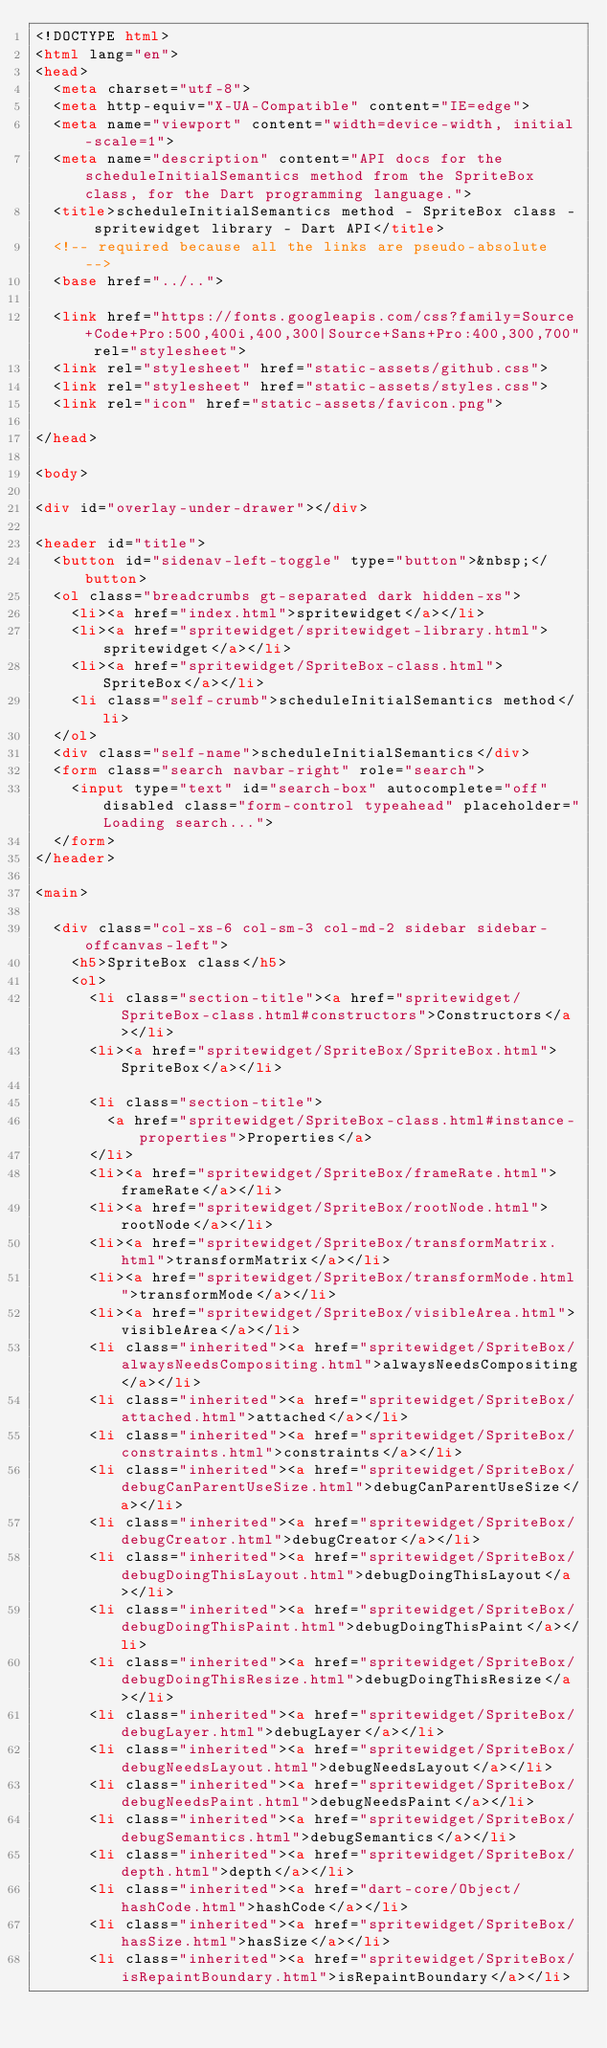Convert code to text. <code><loc_0><loc_0><loc_500><loc_500><_HTML_><!DOCTYPE html>
<html lang="en">
<head>
  <meta charset="utf-8">
  <meta http-equiv="X-UA-Compatible" content="IE=edge">
  <meta name="viewport" content="width=device-width, initial-scale=1">
  <meta name="description" content="API docs for the scheduleInitialSemantics method from the SpriteBox class, for the Dart programming language.">
  <title>scheduleInitialSemantics method - SpriteBox class - spritewidget library - Dart API</title>
  <!-- required because all the links are pseudo-absolute -->
  <base href="../..">

  <link href="https://fonts.googleapis.com/css?family=Source+Code+Pro:500,400i,400,300|Source+Sans+Pro:400,300,700" rel="stylesheet">
  <link rel="stylesheet" href="static-assets/github.css">
  <link rel="stylesheet" href="static-assets/styles.css">
  <link rel="icon" href="static-assets/favicon.png">

</head>

<body>

<div id="overlay-under-drawer"></div>

<header id="title">
  <button id="sidenav-left-toggle" type="button">&nbsp;</button>
  <ol class="breadcrumbs gt-separated dark hidden-xs">
    <li><a href="index.html">spritewidget</a></li>
    <li><a href="spritewidget/spritewidget-library.html">spritewidget</a></li>
    <li><a href="spritewidget/SpriteBox-class.html">SpriteBox</a></li>
    <li class="self-crumb">scheduleInitialSemantics method</li>
  </ol>
  <div class="self-name">scheduleInitialSemantics</div>
  <form class="search navbar-right" role="search">
    <input type="text" id="search-box" autocomplete="off" disabled class="form-control typeahead" placeholder="Loading search...">
  </form>
</header>

<main>

  <div class="col-xs-6 col-sm-3 col-md-2 sidebar sidebar-offcanvas-left">
    <h5>SpriteBox class</h5>
    <ol>
      <li class="section-title"><a href="spritewidget/SpriteBox-class.html#constructors">Constructors</a></li>
      <li><a href="spritewidget/SpriteBox/SpriteBox.html">SpriteBox</a></li>
    
      <li class="section-title">
        <a href="spritewidget/SpriteBox-class.html#instance-properties">Properties</a>
      </li>
      <li><a href="spritewidget/SpriteBox/frameRate.html">frameRate</a></li>
      <li><a href="spritewidget/SpriteBox/rootNode.html">rootNode</a></li>
      <li><a href="spritewidget/SpriteBox/transformMatrix.html">transformMatrix</a></li>
      <li><a href="spritewidget/SpriteBox/transformMode.html">transformMode</a></li>
      <li><a href="spritewidget/SpriteBox/visibleArea.html">visibleArea</a></li>
      <li class="inherited"><a href="spritewidget/SpriteBox/alwaysNeedsCompositing.html">alwaysNeedsCompositing</a></li>
      <li class="inherited"><a href="spritewidget/SpriteBox/attached.html">attached</a></li>
      <li class="inherited"><a href="spritewidget/SpriteBox/constraints.html">constraints</a></li>
      <li class="inherited"><a href="spritewidget/SpriteBox/debugCanParentUseSize.html">debugCanParentUseSize</a></li>
      <li class="inherited"><a href="spritewidget/SpriteBox/debugCreator.html">debugCreator</a></li>
      <li class="inherited"><a href="spritewidget/SpriteBox/debugDoingThisLayout.html">debugDoingThisLayout</a></li>
      <li class="inherited"><a href="spritewidget/SpriteBox/debugDoingThisPaint.html">debugDoingThisPaint</a></li>
      <li class="inherited"><a href="spritewidget/SpriteBox/debugDoingThisResize.html">debugDoingThisResize</a></li>
      <li class="inherited"><a href="spritewidget/SpriteBox/debugLayer.html">debugLayer</a></li>
      <li class="inherited"><a href="spritewidget/SpriteBox/debugNeedsLayout.html">debugNeedsLayout</a></li>
      <li class="inherited"><a href="spritewidget/SpriteBox/debugNeedsPaint.html">debugNeedsPaint</a></li>
      <li class="inherited"><a href="spritewidget/SpriteBox/debugSemantics.html">debugSemantics</a></li>
      <li class="inherited"><a href="spritewidget/SpriteBox/depth.html">depth</a></li>
      <li class="inherited"><a href="dart-core/Object/hashCode.html">hashCode</a></li>
      <li class="inherited"><a href="spritewidget/SpriteBox/hasSize.html">hasSize</a></li>
      <li class="inherited"><a href="spritewidget/SpriteBox/isRepaintBoundary.html">isRepaintBoundary</a></li></code> 